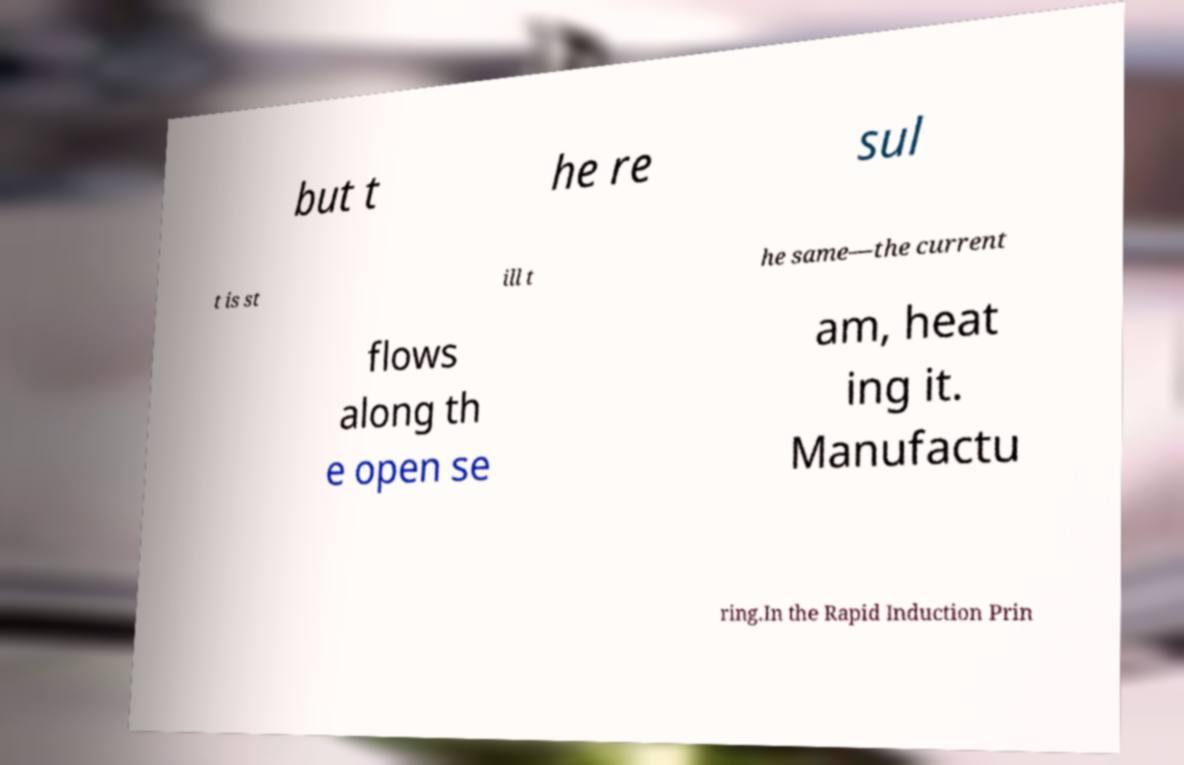What messages or text are displayed in this image? I need them in a readable, typed format. but t he re sul t is st ill t he same—the current flows along th e open se am, heat ing it. Manufactu ring.In the Rapid Induction Prin 